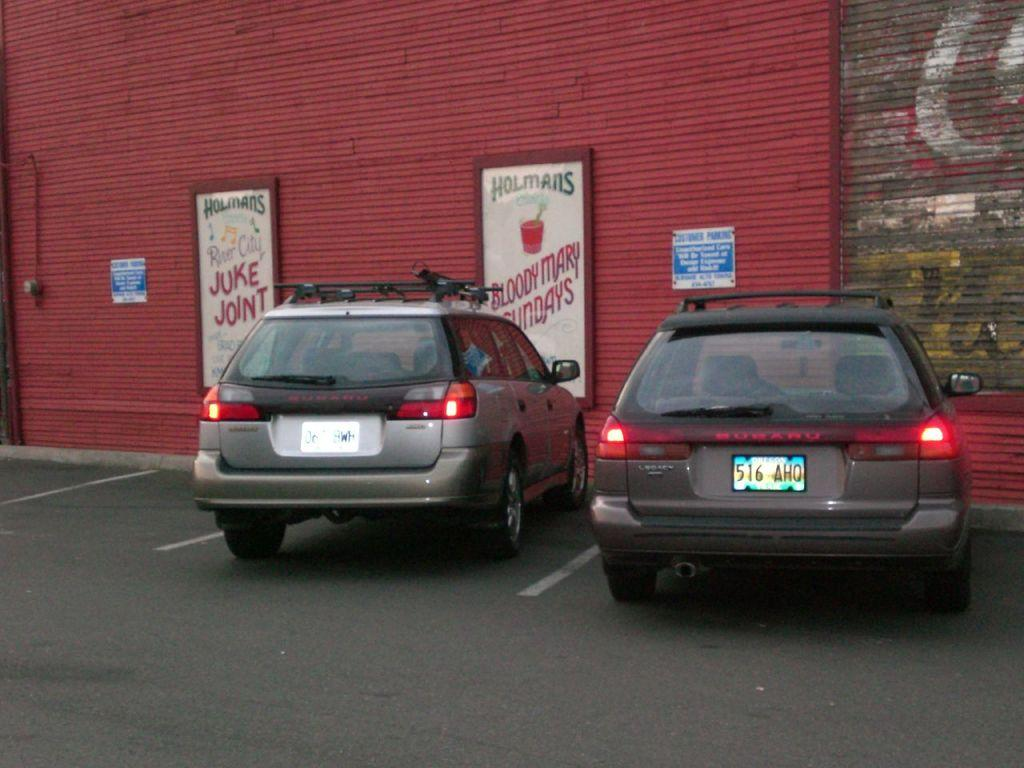<image>
Summarize the visual content of the image. Two vehicles are parked near a sign that reads Juke joint on it. 